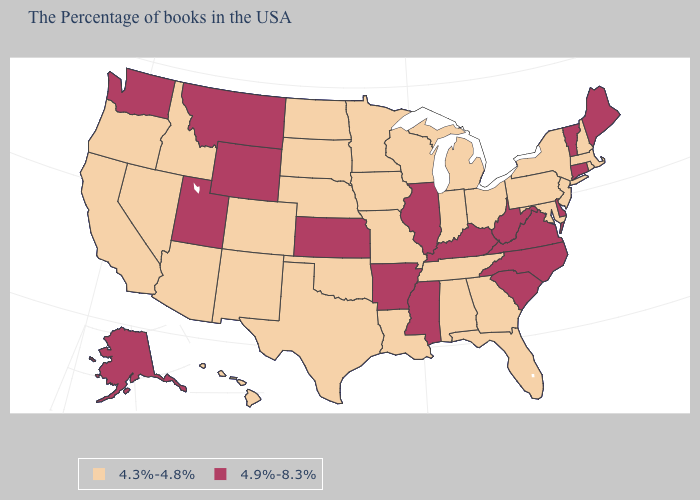What is the value of Minnesota?
Write a very short answer. 4.3%-4.8%. Name the states that have a value in the range 4.3%-4.8%?
Be succinct. Massachusetts, Rhode Island, New Hampshire, New York, New Jersey, Maryland, Pennsylvania, Ohio, Florida, Georgia, Michigan, Indiana, Alabama, Tennessee, Wisconsin, Louisiana, Missouri, Minnesota, Iowa, Nebraska, Oklahoma, Texas, South Dakota, North Dakota, Colorado, New Mexico, Arizona, Idaho, Nevada, California, Oregon, Hawaii. What is the value of California?
Keep it brief. 4.3%-4.8%. Name the states that have a value in the range 4.3%-4.8%?
Concise answer only. Massachusetts, Rhode Island, New Hampshire, New York, New Jersey, Maryland, Pennsylvania, Ohio, Florida, Georgia, Michigan, Indiana, Alabama, Tennessee, Wisconsin, Louisiana, Missouri, Minnesota, Iowa, Nebraska, Oklahoma, Texas, South Dakota, North Dakota, Colorado, New Mexico, Arizona, Idaho, Nevada, California, Oregon, Hawaii. What is the lowest value in the USA?
Give a very brief answer. 4.3%-4.8%. What is the lowest value in states that border Illinois?
Answer briefly. 4.3%-4.8%. Name the states that have a value in the range 4.3%-4.8%?
Answer briefly. Massachusetts, Rhode Island, New Hampshire, New York, New Jersey, Maryland, Pennsylvania, Ohio, Florida, Georgia, Michigan, Indiana, Alabama, Tennessee, Wisconsin, Louisiana, Missouri, Minnesota, Iowa, Nebraska, Oklahoma, Texas, South Dakota, North Dakota, Colorado, New Mexico, Arizona, Idaho, Nevada, California, Oregon, Hawaii. Is the legend a continuous bar?
Concise answer only. No. Name the states that have a value in the range 4.9%-8.3%?
Write a very short answer. Maine, Vermont, Connecticut, Delaware, Virginia, North Carolina, South Carolina, West Virginia, Kentucky, Illinois, Mississippi, Arkansas, Kansas, Wyoming, Utah, Montana, Washington, Alaska. Which states have the lowest value in the USA?
Be succinct. Massachusetts, Rhode Island, New Hampshire, New York, New Jersey, Maryland, Pennsylvania, Ohio, Florida, Georgia, Michigan, Indiana, Alabama, Tennessee, Wisconsin, Louisiana, Missouri, Minnesota, Iowa, Nebraska, Oklahoma, Texas, South Dakota, North Dakota, Colorado, New Mexico, Arizona, Idaho, Nevada, California, Oregon, Hawaii. Does Delaware have the lowest value in the USA?
Keep it brief. No. Name the states that have a value in the range 4.9%-8.3%?
Concise answer only. Maine, Vermont, Connecticut, Delaware, Virginia, North Carolina, South Carolina, West Virginia, Kentucky, Illinois, Mississippi, Arkansas, Kansas, Wyoming, Utah, Montana, Washington, Alaska. Does the first symbol in the legend represent the smallest category?
Keep it brief. Yes. What is the highest value in the USA?
Answer briefly. 4.9%-8.3%. How many symbols are there in the legend?
Be succinct. 2. 